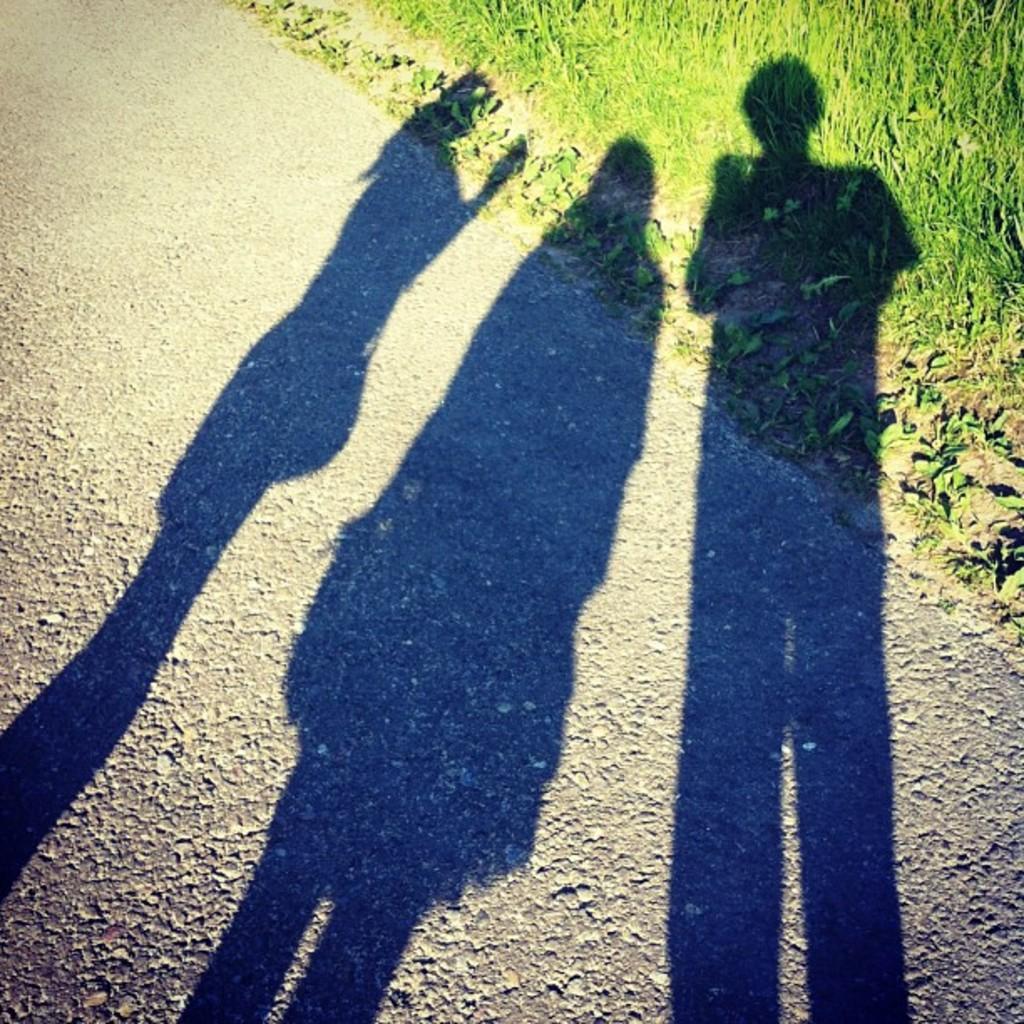Can you describe this image briefly? We can see shadow of three persons and we can see road and grass. 